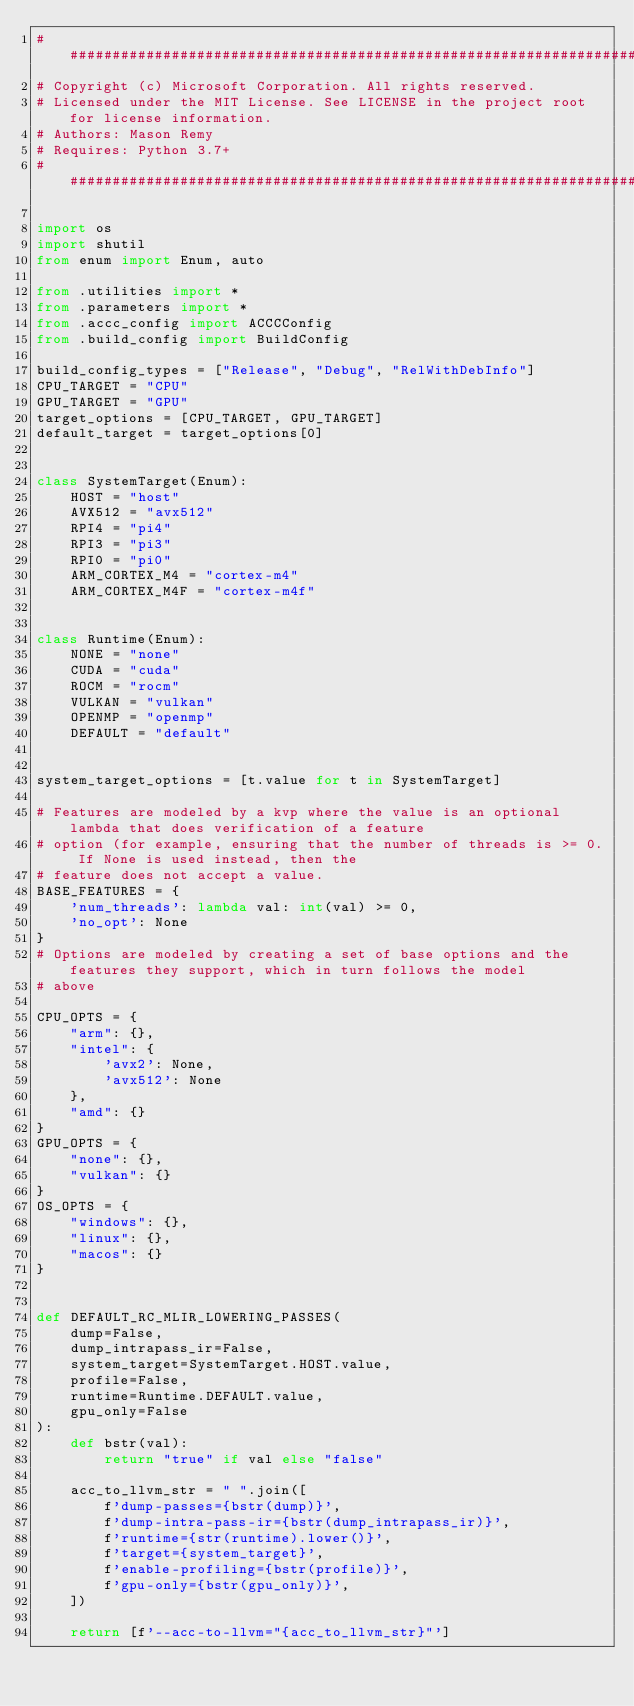Convert code to text. <code><loc_0><loc_0><loc_500><loc_500><_Python_>####################################################################################################
# Copyright (c) Microsoft Corporation. All rights reserved.
# Licensed under the MIT License. See LICENSE in the project root for license information.
# Authors: Mason Remy
# Requires: Python 3.7+
####################################################################################################

import os
import shutil
from enum import Enum, auto

from .utilities import *
from .parameters import *
from .accc_config import ACCCConfig
from .build_config import BuildConfig

build_config_types = ["Release", "Debug", "RelWithDebInfo"]
CPU_TARGET = "CPU"
GPU_TARGET = "GPU"
target_options = [CPU_TARGET, GPU_TARGET]
default_target = target_options[0]


class SystemTarget(Enum):
    HOST = "host"
    AVX512 = "avx512"
    RPI4 = "pi4"
    RPI3 = "pi3"
    RPI0 = "pi0"
    ARM_CORTEX_M4 = "cortex-m4"
    ARM_CORTEX_M4F = "cortex-m4f"


class Runtime(Enum):
    NONE = "none"
    CUDA = "cuda"
    ROCM = "rocm"
    VULKAN = "vulkan"
    OPENMP = "openmp"
    DEFAULT = "default"


system_target_options = [t.value for t in SystemTarget]

# Features are modeled by a kvp where the value is an optional lambda that does verification of a feature
# option (for example, ensuring that the number of threads is >= 0. If None is used instead, then the
# feature does not accept a value.
BASE_FEATURES = {
    'num_threads': lambda val: int(val) >= 0,
    'no_opt': None
}
# Options are modeled by creating a set of base options and the features they support, which in turn follows the model
# above

CPU_OPTS = {
    "arm": {},
    "intel": {
        'avx2': None,
        'avx512': None
    },
    "amd": {}
}
GPU_OPTS = {
    "none": {},
    "vulkan": {}
}
OS_OPTS = {
    "windows": {},
    "linux": {},
    "macos": {}
}


def DEFAULT_RC_MLIR_LOWERING_PASSES(
    dump=False,
    dump_intrapass_ir=False,
    system_target=SystemTarget.HOST.value,
    profile=False,
    runtime=Runtime.DEFAULT.value,
    gpu_only=False
):
    def bstr(val):
        return "true" if val else "false"

    acc_to_llvm_str = " ".join([
        f'dump-passes={bstr(dump)}',
        f'dump-intra-pass-ir={bstr(dump_intrapass_ir)}',
        f'runtime={str(runtime).lower()}',
        f'target={system_target}',
        f'enable-profiling={bstr(profile)}',
        f'gpu-only={bstr(gpu_only)}',
    ])

    return [f'--acc-to-llvm="{acc_to_llvm_str}"']

</code> 